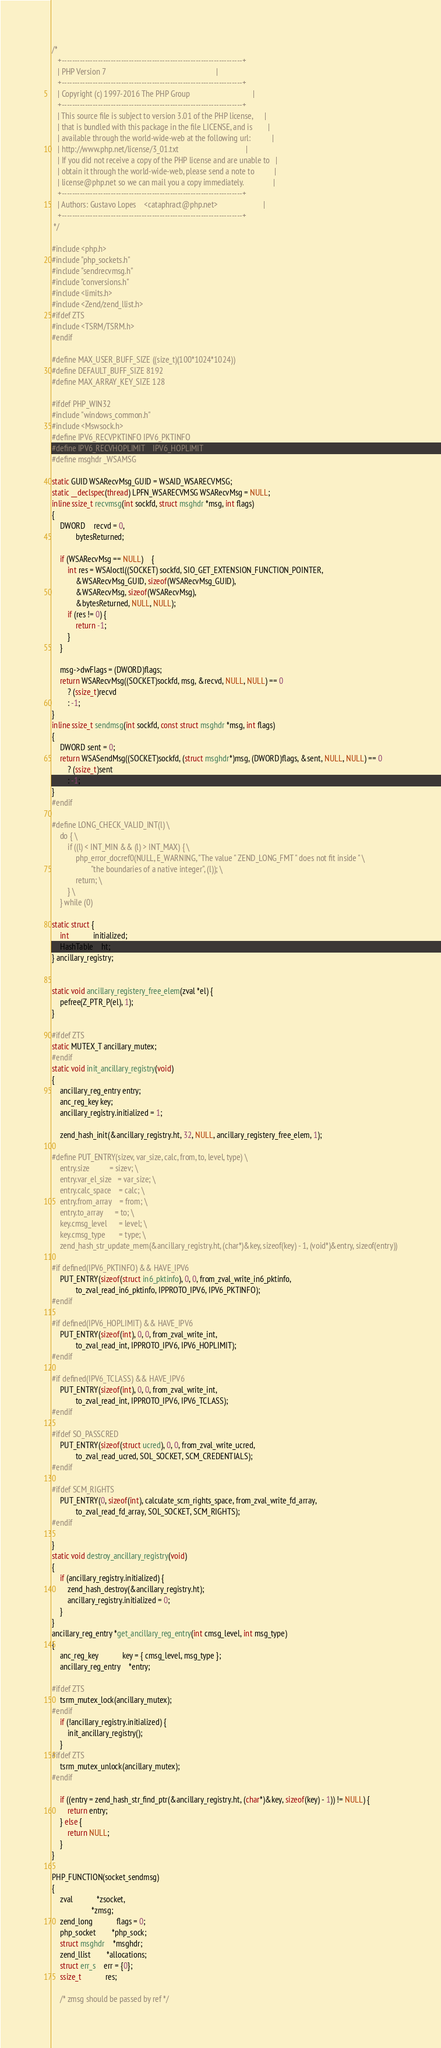Convert code to text. <code><loc_0><loc_0><loc_500><loc_500><_C_>/*
   +----------------------------------------------------------------------+
   | PHP Version 7                                                        |
   +----------------------------------------------------------------------+
   | Copyright (c) 1997-2016 The PHP Group                                |
   +----------------------------------------------------------------------+
   | This source file is subject to version 3.01 of the PHP license,      |
   | that is bundled with this package in the file LICENSE, and is        |
   | available through the world-wide-web at the following url:           |
   | http://www.php.net/license/3_01.txt                                  |
   | If you did not receive a copy of the PHP license and are unable to   |
   | obtain it through the world-wide-web, please send a note to          |
   | license@php.net so we can mail you a copy immediately.               |
   +----------------------------------------------------------------------+
   | Authors: Gustavo Lopes    <cataphract@php.net>                       |
   +----------------------------------------------------------------------+
 */

#include <php.h>
#include "php_sockets.h"
#include "sendrecvmsg.h"
#include "conversions.h"
#include <limits.h>
#include <Zend/zend_llist.h>
#ifdef ZTS
#include <TSRM/TSRM.h>
#endif

#define MAX_USER_BUFF_SIZE ((size_t)(100*1024*1024))
#define DEFAULT_BUFF_SIZE 8192
#define MAX_ARRAY_KEY_SIZE 128

#ifdef PHP_WIN32
#include "windows_common.h"
#include <Mswsock.h>
#define IPV6_RECVPKTINFO	IPV6_PKTINFO
#define IPV6_RECVHOPLIMIT	IPV6_HOPLIMIT
#define msghdr _WSAMSG

static GUID WSARecvMsg_GUID = WSAID_WSARECVMSG;
static __declspec(thread) LPFN_WSARECVMSG WSARecvMsg = NULL;
inline ssize_t recvmsg(int sockfd, struct msghdr *msg, int flags)
{
	DWORD	recvd = 0,
			bytesReturned;

	if (WSARecvMsg == NULL)	{
		int res = WSAIoctl((SOCKET) sockfd, SIO_GET_EXTENSION_FUNCTION_POINTER,
			&WSARecvMsg_GUID, sizeof(WSARecvMsg_GUID),
			&WSARecvMsg, sizeof(WSARecvMsg),
			&bytesReturned, NULL, NULL);
		if (res != 0) {
			return -1;
		}
	}

	msg->dwFlags = (DWORD)flags;
	return WSARecvMsg((SOCKET)sockfd, msg, &recvd, NULL, NULL) == 0
		? (ssize_t)recvd
		: -1;
}
inline ssize_t sendmsg(int sockfd, const struct msghdr *msg, int flags)
{
	DWORD sent = 0;
	return WSASendMsg((SOCKET)sockfd, (struct msghdr*)msg, (DWORD)flags, &sent, NULL, NULL) == 0
		? (ssize_t)sent
		: -1;
}
#endif

#define LONG_CHECK_VALID_INT(l) \
	do { \
		if ((l) < INT_MIN && (l) > INT_MAX) { \
			php_error_docref0(NULL, E_WARNING, "The value " ZEND_LONG_FMT " does not fit inside " \
					"the boundaries of a native integer", (l)); \
			return; \
		} \
	} while (0)

static struct {
	int			initialized;
	HashTable	ht;
} ancillary_registry;


static void ancillary_registery_free_elem(zval *el) {
	pefree(Z_PTR_P(el), 1);
}

#ifdef ZTS
static MUTEX_T ancillary_mutex;
#endif
static void init_ancillary_registry(void)
{
	ancillary_reg_entry entry;
	anc_reg_key key;
	ancillary_registry.initialized = 1;

	zend_hash_init(&ancillary_registry.ht, 32, NULL, ancillary_registery_free_elem, 1);

#define PUT_ENTRY(sizev, var_size, calc, from, to, level, type) \
	entry.size			= sizev; \
	entry.var_el_size	= var_size; \
	entry.calc_space	= calc; \
	entry.from_array	= from; \
	entry.to_array		= to; \
	key.cmsg_level		= level; \
	key.cmsg_type		= type; \
	zend_hash_str_update_mem(&ancillary_registry.ht, (char*)&key, sizeof(key) - 1, (void*)&entry, sizeof(entry))

#if defined(IPV6_PKTINFO) && HAVE_IPV6
	PUT_ENTRY(sizeof(struct in6_pktinfo), 0, 0, from_zval_write_in6_pktinfo,
			to_zval_read_in6_pktinfo, IPPROTO_IPV6, IPV6_PKTINFO);
#endif

#if defined(IPV6_HOPLIMIT) && HAVE_IPV6
	PUT_ENTRY(sizeof(int), 0, 0, from_zval_write_int,
			to_zval_read_int, IPPROTO_IPV6, IPV6_HOPLIMIT);
#endif

#if defined(IPV6_TCLASS) && HAVE_IPV6
	PUT_ENTRY(sizeof(int), 0, 0, from_zval_write_int,
			to_zval_read_int, IPPROTO_IPV6, IPV6_TCLASS);
#endif

#ifdef SO_PASSCRED
	PUT_ENTRY(sizeof(struct ucred), 0, 0, from_zval_write_ucred,
			to_zval_read_ucred, SOL_SOCKET, SCM_CREDENTIALS);
#endif

#ifdef SCM_RIGHTS
	PUT_ENTRY(0, sizeof(int), calculate_scm_rights_space, from_zval_write_fd_array,
			to_zval_read_fd_array, SOL_SOCKET, SCM_RIGHTS);
#endif

}
static void destroy_ancillary_registry(void)
{
	if (ancillary_registry.initialized) {
		zend_hash_destroy(&ancillary_registry.ht);
		ancillary_registry.initialized = 0;
	}
}
ancillary_reg_entry *get_ancillary_reg_entry(int cmsg_level, int msg_type)
{
	anc_reg_key			key = { cmsg_level, msg_type };
	ancillary_reg_entry	*entry;

#ifdef ZTS
	tsrm_mutex_lock(ancillary_mutex);
#endif
	if (!ancillary_registry.initialized) {
		init_ancillary_registry();
	}
#ifdef ZTS
	tsrm_mutex_unlock(ancillary_mutex);
#endif

	if ((entry = zend_hash_str_find_ptr(&ancillary_registry.ht, (char*)&key, sizeof(key) - 1)) != NULL) {
		return entry;
	} else {
		return NULL;
	}
}

PHP_FUNCTION(socket_sendmsg)
{
	zval			*zsocket,
					*zmsg;
	zend_long			flags = 0;
	php_socket		*php_sock;
	struct msghdr	*msghdr;
	zend_llist		*allocations;
	struct err_s	err = {0};
	ssize_t			res;

	/* zmsg should be passed by ref */</code> 